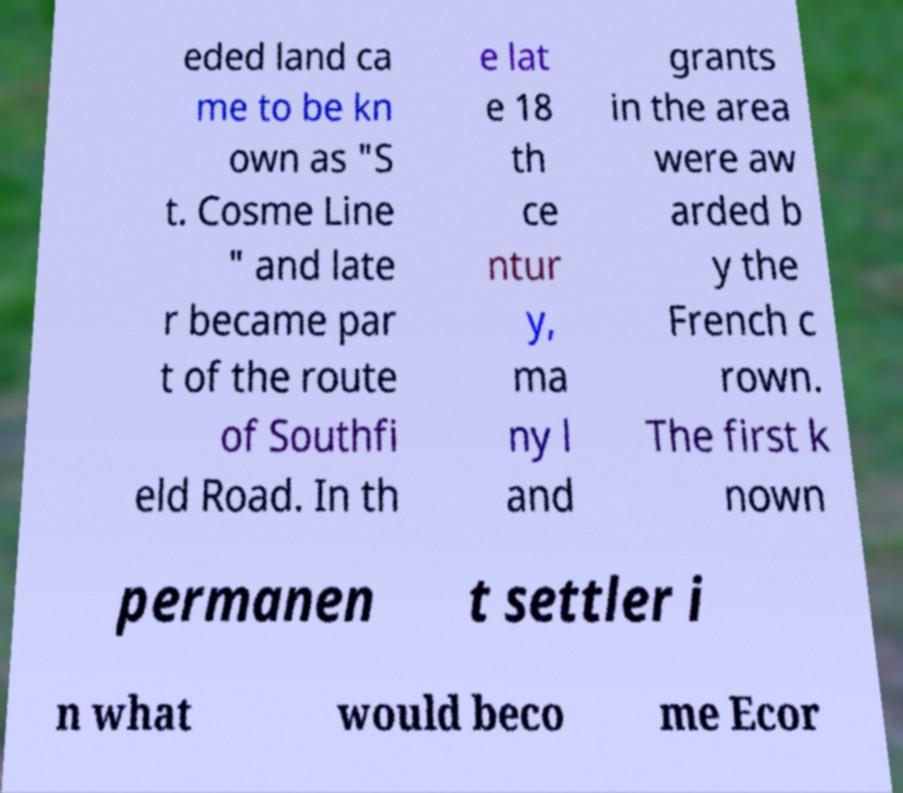What messages or text are displayed in this image? I need them in a readable, typed format. eded land ca me to be kn own as "S t. Cosme Line " and late r became par t of the route of Southfi eld Road. In th e lat e 18 th ce ntur y, ma ny l and grants in the area were aw arded b y the French c rown. The first k nown permanen t settler i n what would beco me Ecor 